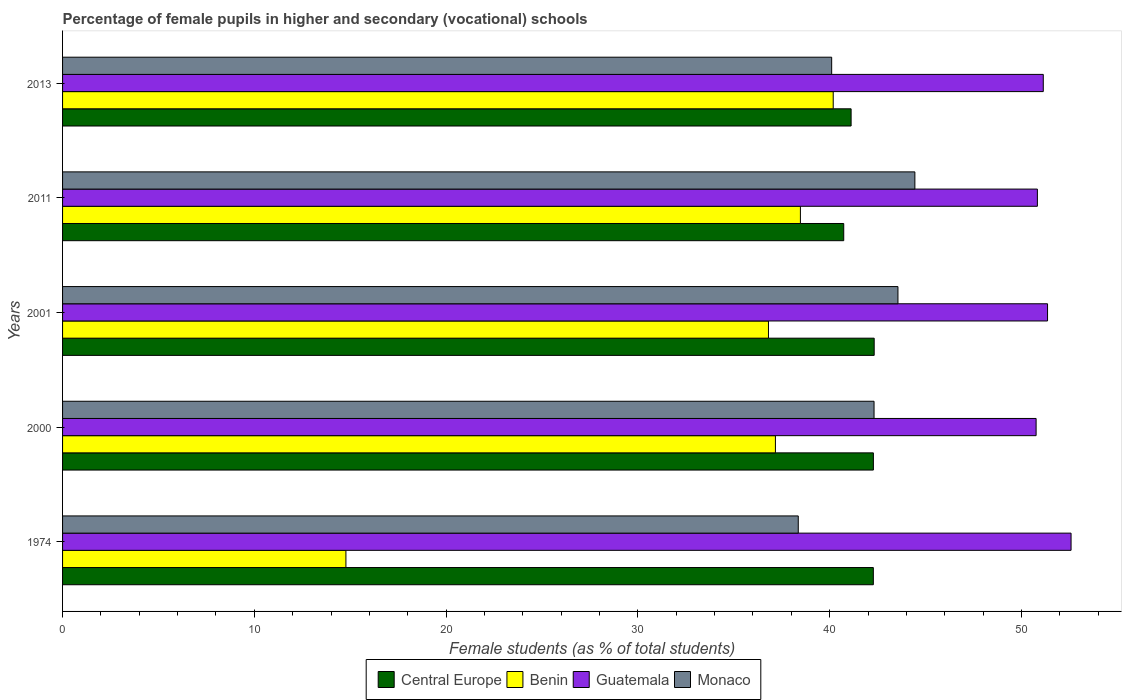How many different coloured bars are there?
Your answer should be compact. 4. How many groups of bars are there?
Keep it short and to the point. 5. Are the number of bars per tick equal to the number of legend labels?
Keep it short and to the point. Yes. Are the number of bars on each tick of the Y-axis equal?
Your response must be concise. Yes. How many bars are there on the 5th tick from the bottom?
Make the answer very short. 4. What is the label of the 2nd group of bars from the top?
Provide a succinct answer. 2011. What is the percentage of female pupils in higher and secondary schools in Benin in 2000?
Your response must be concise. 37.17. Across all years, what is the maximum percentage of female pupils in higher and secondary schools in Monaco?
Give a very brief answer. 44.44. Across all years, what is the minimum percentage of female pupils in higher and secondary schools in Benin?
Provide a short and direct response. 14.78. In which year was the percentage of female pupils in higher and secondary schools in Guatemala maximum?
Provide a short and direct response. 1974. What is the total percentage of female pupils in higher and secondary schools in Monaco in the graph?
Keep it short and to the point. 208.79. What is the difference between the percentage of female pupils in higher and secondary schools in Central Europe in 1974 and that in 2013?
Your answer should be compact. 1.16. What is the difference between the percentage of female pupils in higher and secondary schools in Central Europe in 2011 and the percentage of female pupils in higher and secondary schools in Guatemala in 2013?
Give a very brief answer. -10.41. What is the average percentage of female pupils in higher and secondary schools in Guatemala per year?
Offer a very short reply. 51.34. In the year 2013, what is the difference between the percentage of female pupils in higher and secondary schools in Central Europe and percentage of female pupils in higher and secondary schools in Monaco?
Offer a very short reply. 1.01. What is the ratio of the percentage of female pupils in higher and secondary schools in Guatemala in 2000 to that in 2011?
Offer a terse response. 1. Is the difference between the percentage of female pupils in higher and secondary schools in Central Europe in 1974 and 2013 greater than the difference between the percentage of female pupils in higher and secondary schools in Monaco in 1974 and 2013?
Offer a very short reply. Yes. What is the difference between the highest and the second highest percentage of female pupils in higher and secondary schools in Monaco?
Make the answer very short. 0.88. What is the difference between the highest and the lowest percentage of female pupils in higher and secondary schools in Central Europe?
Keep it short and to the point. 1.59. In how many years, is the percentage of female pupils in higher and secondary schools in Monaco greater than the average percentage of female pupils in higher and secondary schools in Monaco taken over all years?
Your response must be concise. 3. Is the sum of the percentage of female pupils in higher and secondary schools in Guatemala in 2011 and 2013 greater than the maximum percentage of female pupils in higher and secondary schools in Central Europe across all years?
Keep it short and to the point. Yes. Is it the case that in every year, the sum of the percentage of female pupils in higher and secondary schools in Central Europe and percentage of female pupils in higher and secondary schools in Monaco is greater than the sum of percentage of female pupils in higher and secondary schools in Benin and percentage of female pupils in higher and secondary schools in Guatemala?
Give a very brief answer. Yes. What does the 4th bar from the top in 1974 represents?
Keep it short and to the point. Central Europe. What does the 1st bar from the bottom in 2001 represents?
Give a very brief answer. Central Europe. Does the graph contain grids?
Give a very brief answer. No. How are the legend labels stacked?
Provide a succinct answer. Horizontal. What is the title of the graph?
Your response must be concise. Percentage of female pupils in higher and secondary (vocational) schools. What is the label or title of the X-axis?
Offer a terse response. Female students (as % of total students). What is the Female students (as % of total students) in Central Europe in 1974?
Your answer should be compact. 42.28. What is the Female students (as % of total students) in Benin in 1974?
Your answer should be compact. 14.78. What is the Female students (as % of total students) in Guatemala in 1974?
Keep it short and to the point. 52.59. What is the Female students (as % of total students) in Monaco in 1974?
Provide a short and direct response. 38.36. What is the Female students (as % of total students) of Central Europe in 2000?
Give a very brief answer. 42.28. What is the Female students (as % of total students) of Benin in 2000?
Your response must be concise. 37.17. What is the Female students (as % of total students) in Guatemala in 2000?
Give a very brief answer. 50.77. What is the Female students (as % of total students) in Monaco in 2000?
Offer a terse response. 42.32. What is the Female students (as % of total students) in Central Europe in 2001?
Offer a very short reply. 42.32. What is the Female students (as % of total students) of Benin in 2001?
Keep it short and to the point. 36.81. What is the Female students (as % of total students) in Guatemala in 2001?
Make the answer very short. 51.36. What is the Female students (as % of total students) in Monaco in 2001?
Your answer should be compact. 43.56. What is the Female students (as % of total students) of Central Europe in 2011?
Keep it short and to the point. 40.73. What is the Female students (as % of total students) in Benin in 2011?
Keep it short and to the point. 38.48. What is the Female students (as % of total students) in Guatemala in 2011?
Your answer should be compact. 50.83. What is the Female students (as % of total students) of Monaco in 2011?
Your answer should be compact. 44.44. What is the Female students (as % of total students) in Central Europe in 2013?
Your answer should be compact. 41.12. What is the Female students (as % of total students) of Benin in 2013?
Give a very brief answer. 40.19. What is the Female students (as % of total students) of Guatemala in 2013?
Your answer should be compact. 51.14. What is the Female students (as % of total students) in Monaco in 2013?
Keep it short and to the point. 40.11. Across all years, what is the maximum Female students (as % of total students) of Central Europe?
Offer a very short reply. 42.32. Across all years, what is the maximum Female students (as % of total students) in Benin?
Give a very brief answer. 40.19. Across all years, what is the maximum Female students (as % of total students) in Guatemala?
Your response must be concise. 52.59. Across all years, what is the maximum Female students (as % of total students) in Monaco?
Provide a succinct answer. 44.44. Across all years, what is the minimum Female students (as % of total students) in Central Europe?
Offer a very short reply. 40.73. Across all years, what is the minimum Female students (as % of total students) in Benin?
Provide a succinct answer. 14.78. Across all years, what is the minimum Female students (as % of total students) of Guatemala?
Your answer should be very brief. 50.77. Across all years, what is the minimum Female students (as % of total students) of Monaco?
Provide a short and direct response. 38.36. What is the total Female students (as % of total students) of Central Europe in the graph?
Give a very brief answer. 208.74. What is the total Female students (as % of total students) of Benin in the graph?
Make the answer very short. 167.42. What is the total Female students (as % of total students) of Guatemala in the graph?
Provide a succinct answer. 256.69. What is the total Female students (as % of total students) in Monaco in the graph?
Ensure brevity in your answer.  208.79. What is the difference between the Female students (as % of total students) of Central Europe in 1974 and that in 2000?
Give a very brief answer. -0. What is the difference between the Female students (as % of total students) of Benin in 1974 and that in 2000?
Give a very brief answer. -22.4. What is the difference between the Female students (as % of total students) of Guatemala in 1974 and that in 2000?
Make the answer very short. 1.82. What is the difference between the Female students (as % of total students) in Monaco in 1974 and that in 2000?
Provide a succinct answer. -3.95. What is the difference between the Female students (as % of total students) in Central Europe in 1974 and that in 2001?
Offer a very short reply. -0.04. What is the difference between the Female students (as % of total students) in Benin in 1974 and that in 2001?
Your response must be concise. -22.03. What is the difference between the Female students (as % of total students) in Guatemala in 1974 and that in 2001?
Your answer should be compact. 1.23. What is the difference between the Female students (as % of total students) of Monaco in 1974 and that in 2001?
Provide a short and direct response. -5.2. What is the difference between the Female students (as % of total students) of Central Europe in 1974 and that in 2011?
Provide a succinct answer. 1.54. What is the difference between the Female students (as % of total students) of Benin in 1974 and that in 2011?
Your answer should be very brief. -23.7. What is the difference between the Female students (as % of total students) of Guatemala in 1974 and that in 2011?
Offer a terse response. 1.76. What is the difference between the Female students (as % of total students) in Monaco in 1974 and that in 2011?
Provide a short and direct response. -6.08. What is the difference between the Female students (as % of total students) in Central Europe in 1974 and that in 2013?
Keep it short and to the point. 1.16. What is the difference between the Female students (as % of total students) of Benin in 1974 and that in 2013?
Offer a very short reply. -25.41. What is the difference between the Female students (as % of total students) of Guatemala in 1974 and that in 2013?
Make the answer very short. 1.45. What is the difference between the Female students (as % of total students) of Monaco in 1974 and that in 2013?
Your response must be concise. -1.74. What is the difference between the Female students (as % of total students) of Central Europe in 2000 and that in 2001?
Offer a very short reply. -0.04. What is the difference between the Female students (as % of total students) of Benin in 2000 and that in 2001?
Provide a succinct answer. 0.36. What is the difference between the Female students (as % of total students) in Guatemala in 2000 and that in 2001?
Ensure brevity in your answer.  -0.6. What is the difference between the Female students (as % of total students) in Monaco in 2000 and that in 2001?
Give a very brief answer. -1.25. What is the difference between the Female students (as % of total students) of Central Europe in 2000 and that in 2011?
Make the answer very short. 1.55. What is the difference between the Female students (as % of total students) in Benin in 2000 and that in 2011?
Give a very brief answer. -1.3. What is the difference between the Female students (as % of total students) in Guatemala in 2000 and that in 2011?
Provide a succinct answer. -0.07. What is the difference between the Female students (as % of total students) of Monaco in 2000 and that in 2011?
Keep it short and to the point. -2.13. What is the difference between the Female students (as % of total students) of Central Europe in 2000 and that in 2013?
Your answer should be compact. 1.16. What is the difference between the Female students (as % of total students) of Benin in 2000 and that in 2013?
Provide a succinct answer. -3.01. What is the difference between the Female students (as % of total students) in Guatemala in 2000 and that in 2013?
Keep it short and to the point. -0.37. What is the difference between the Female students (as % of total students) of Monaco in 2000 and that in 2013?
Make the answer very short. 2.21. What is the difference between the Female students (as % of total students) of Central Europe in 2001 and that in 2011?
Your response must be concise. 1.59. What is the difference between the Female students (as % of total students) in Benin in 2001 and that in 2011?
Your response must be concise. -1.67. What is the difference between the Female students (as % of total students) of Guatemala in 2001 and that in 2011?
Give a very brief answer. 0.53. What is the difference between the Female students (as % of total students) of Monaco in 2001 and that in 2011?
Give a very brief answer. -0.88. What is the difference between the Female students (as % of total students) in Central Europe in 2001 and that in 2013?
Your answer should be compact. 1.2. What is the difference between the Female students (as % of total students) in Benin in 2001 and that in 2013?
Your response must be concise. -3.38. What is the difference between the Female students (as % of total students) of Guatemala in 2001 and that in 2013?
Your answer should be very brief. 0.22. What is the difference between the Female students (as % of total students) in Monaco in 2001 and that in 2013?
Keep it short and to the point. 3.46. What is the difference between the Female students (as % of total students) in Central Europe in 2011 and that in 2013?
Provide a short and direct response. -0.38. What is the difference between the Female students (as % of total students) in Benin in 2011 and that in 2013?
Provide a succinct answer. -1.71. What is the difference between the Female students (as % of total students) of Guatemala in 2011 and that in 2013?
Offer a very short reply. -0.31. What is the difference between the Female students (as % of total students) in Monaco in 2011 and that in 2013?
Offer a terse response. 4.34. What is the difference between the Female students (as % of total students) of Central Europe in 1974 and the Female students (as % of total students) of Benin in 2000?
Offer a terse response. 5.11. What is the difference between the Female students (as % of total students) in Central Europe in 1974 and the Female students (as % of total students) in Guatemala in 2000?
Offer a terse response. -8.49. What is the difference between the Female students (as % of total students) of Central Europe in 1974 and the Female students (as % of total students) of Monaco in 2000?
Provide a succinct answer. -0.04. What is the difference between the Female students (as % of total students) in Benin in 1974 and the Female students (as % of total students) in Guatemala in 2000?
Your answer should be very brief. -35.99. What is the difference between the Female students (as % of total students) of Benin in 1974 and the Female students (as % of total students) of Monaco in 2000?
Provide a short and direct response. -27.54. What is the difference between the Female students (as % of total students) of Guatemala in 1974 and the Female students (as % of total students) of Monaco in 2000?
Give a very brief answer. 10.27. What is the difference between the Female students (as % of total students) in Central Europe in 1974 and the Female students (as % of total students) in Benin in 2001?
Offer a very short reply. 5.47. What is the difference between the Female students (as % of total students) in Central Europe in 1974 and the Female students (as % of total students) in Guatemala in 2001?
Ensure brevity in your answer.  -9.08. What is the difference between the Female students (as % of total students) in Central Europe in 1974 and the Female students (as % of total students) in Monaco in 2001?
Your response must be concise. -1.28. What is the difference between the Female students (as % of total students) of Benin in 1974 and the Female students (as % of total students) of Guatemala in 2001?
Make the answer very short. -36.59. What is the difference between the Female students (as % of total students) in Benin in 1974 and the Female students (as % of total students) in Monaco in 2001?
Provide a succinct answer. -28.79. What is the difference between the Female students (as % of total students) in Guatemala in 1974 and the Female students (as % of total students) in Monaco in 2001?
Give a very brief answer. 9.03. What is the difference between the Female students (as % of total students) in Central Europe in 1974 and the Female students (as % of total students) in Benin in 2011?
Give a very brief answer. 3.8. What is the difference between the Female students (as % of total students) in Central Europe in 1974 and the Female students (as % of total students) in Guatemala in 2011?
Provide a succinct answer. -8.56. What is the difference between the Female students (as % of total students) in Central Europe in 1974 and the Female students (as % of total students) in Monaco in 2011?
Your answer should be very brief. -2.17. What is the difference between the Female students (as % of total students) in Benin in 1974 and the Female students (as % of total students) in Guatemala in 2011?
Your answer should be compact. -36.06. What is the difference between the Female students (as % of total students) of Benin in 1974 and the Female students (as % of total students) of Monaco in 2011?
Your answer should be very brief. -29.67. What is the difference between the Female students (as % of total students) of Guatemala in 1974 and the Female students (as % of total students) of Monaco in 2011?
Your answer should be compact. 8.14. What is the difference between the Female students (as % of total students) in Central Europe in 1974 and the Female students (as % of total students) in Benin in 2013?
Offer a terse response. 2.09. What is the difference between the Female students (as % of total students) in Central Europe in 1974 and the Female students (as % of total students) in Guatemala in 2013?
Provide a succinct answer. -8.86. What is the difference between the Female students (as % of total students) in Central Europe in 1974 and the Female students (as % of total students) in Monaco in 2013?
Ensure brevity in your answer.  2.17. What is the difference between the Female students (as % of total students) of Benin in 1974 and the Female students (as % of total students) of Guatemala in 2013?
Your answer should be very brief. -36.36. What is the difference between the Female students (as % of total students) in Benin in 1974 and the Female students (as % of total students) in Monaco in 2013?
Your answer should be very brief. -25.33. What is the difference between the Female students (as % of total students) of Guatemala in 1974 and the Female students (as % of total students) of Monaco in 2013?
Keep it short and to the point. 12.48. What is the difference between the Female students (as % of total students) of Central Europe in 2000 and the Female students (as % of total students) of Benin in 2001?
Provide a short and direct response. 5.47. What is the difference between the Female students (as % of total students) in Central Europe in 2000 and the Female students (as % of total students) in Guatemala in 2001?
Ensure brevity in your answer.  -9.08. What is the difference between the Female students (as % of total students) of Central Europe in 2000 and the Female students (as % of total students) of Monaco in 2001?
Offer a very short reply. -1.28. What is the difference between the Female students (as % of total students) in Benin in 2000 and the Female students (as % of total students) in Guatemala in 2001?
Offer a very short reply. -14.19. What is the difference between the Female students (as % of total students) in Benin in 2000 and the Female students (as % of total students) in Monaco in 2001?
Your answer should be very brief. -6.39. What is the difference between the Female students (as % of total students) of Guatemala in 2000 and the Female students (as % of total students) of Monaco in 2001?
Offer a terse response. 7.2. What is the difference between the Female students (as % of total students) of Central Europe in 2000 and the Female students (as % of total students) of Benin in 2011?
Offer a terse response. 3.81. What is the difference between the Female students (as % of total students) of Central Europe in 2000 and the Female students (as % of total students) of Guatemala in 2011?
Your answer should be very brief. -8.55. What is the difference between the Female students (as % of total students) of Central Europe in 2000 and the Female students (as % of total students) of Monaco in 2011?
Your response must be concise. -2.16. What is the difference between the Female students (as % of total students) of Benin in 2000 and the Female students (as % of total students) of Guatemala in 2011?
Provide a short and direct response. -13.66. What is the difference between the Female students (as % of total students) in Benin in 2000 and the Female students (as % of total students) in Monaco in 2011?
Offer a very short reply. -7.27. What is the difference between the Female students (as % of total students) of Guatemala in 2000 and the Female students (as % of total students) of Monaco in 2011?
Offer a very short reply. 6.32. What is the difference between the Female students (as % of total students) in Central Europe in 2000 and the Female students (as % of total students) in Benin in 2013?
Make the answer very short. 2.1. What is the difference between the Female students (as % of total students) of Central Europe in 2000 and the Female students (as % of total students) of Guatemala in 2013?
Keep it short and to the point. -8.86. What is the difference between the Female students (as % of total students) of Central Europe in 2000 and the Female students (as % of total students) of Monaco in 2013?
Your answer should be very brief. 2.18. What is the difference between the Female students (as % of total students) of Benin in 2000 and the Female students (as % of total students) of Guatemala in 2013?
Give a very brief answer. -13.97. What is the difference between the Female students (as % of total students) of Benin in 2000 and the Female students (as % of total students) of Monaco in 2013?
Give a very brief answer. -2.93. What is the difference between the Female students (as % of total students) of Guatemala in 2000 and the Female students (as % of total students) of Monaco in 2013?
Provide a succinct answer. 10.66. What is the difference between the Female students (as % of total students) in Central Europe in 2001 and the Female students (as % of total students) in Benin in 2011?
Ensure brevity in your answer.  3.85. What is the difference between the Female students (as % of total students) in Central Europe in 2001 and the Female students (as % of total students) in Guatemala in 2011?
Provide a succinct answer. -8.51. What is the difference between the Female students (as % of total students) of Central Europe in 2001 and the Female students (as % of total students) of Monaco in 2011?
Your response must be concise. -2.12. What is the difference between the Female students (as % of total students) in Benin in 2001 and the Female students (as % of total students) in Guatemala in 2011?
Offer a very short reply. -14.02. What is the difference between the Female students (as % of total students) in Benin in 2001 and the Female students (as % of total students) in Monaco in 2011?
Give a very brief answer. -7.63. What is the difference between the Female students (as % of total students) in Guatemala in 2001 and the Female students (as % of total students) in Monaco in 2011?
Your answer should be compact. 6.92. What is the difference between the Female students (as % of total students) in Central Europe in 2001 and the Female students (as % of total students) in Benin in 2013?
Keep it short and to the point. 2.14. What is the difference between the Female students (as % of total students) in Central Europe in 2001 and the Female students (as % of total students) in Guatemala in 2013?
Provide a succinct answer. -8.82. What is the difference between the Female students (as % of total students) of Central Europe in 2001 and the Female students (as % of total students) of Monaco in 2013?
Offer a very short reply. 2.22. What is the difference between the Female students (as % of total students) of Benin in 2001 and the Female students (as % of total students) of Guatemala in 2013?
Keep it short and to the point. -14.33. What is the difference between the Female students (as % of total students) in Benin in 2001 and the Female students (as % of total students) in Monaco in 2013?
Offer a very short reply. -3.3. What is the difference between the Female students (as % of total students) in Guatemala in 2001 and the Female students (as % of total students) in Monaco in 2013?
Your answer should be compact. 11.26. What is the difference between the Female students (as % of total students) of Central Europe in 2011 and the Female students (as % of total students) of Benin in 2013?
Offer a very short reply. 0.55. What is the difference between the Female students (as % of total students) of Central Europe in 2011 and the Female students (as % of total students) of Guatemala in 2013?
Provide a short and direct response. -10.41. What is the difference between the Female students (as % of total students) of Central Europe in 2011 and the Female students (as % of total students) of Monaco in 2013?
Provide a succinct answer. 0.63. What is the difference between the Female students (as % of total students) of Benin in 2011 and the Female students (as % of total students) of Guatemala in 2013?
Offer a terse response. -12.66. What is the difference between the Female students (as % of total students) in Benin in 2011 and the Female students (as % of total students) in Monaco in 2013?
Ensure brevity in your answer.  -1.63. What is the difference between the Female students (as % of total students) in Guatemala in 2011 and the Female students (as % of total students) in Monaco in 2013?
Offer a very short reply. 10.73. What is the average Female students (as % of total students) of Central Europe per year?
Offer a terse response. 41.75. What is the average Female students (as % of total students) of Benin per year?
Your answer should be very brief. 33.48. What is the average Female students (as % of total students) of Guatemala per year?
Give a very brief answer. 51.34. What is the average Female students (as % of total students) of Monaco per year?
Your response must be concise. 41.76. In the year 1974, what is the difference between the Female students (as % of total students) in Central Europe and Female students (as % of total students) in Benin?
Offer a very short reply. 27.5. In the year 1974, what is the difference between the Female students (as % of total students) of Central Europe and Female students (as % of total students) of Guatemala?
Your answer should be very brief. -10.31. In the year 1974, what is the difference between the Female students (as % of total students) of Central Europe and Female students (as % of total students) of Monaco?
Ensure brevity in your answer.  3.91. In the year 1974, what is the difference between the Female students (as % of total students) of Benin and Female students (as % of total students) of Guatemala?
Your response must be concise. -37.81. In the year 1974, what is the difference between the Female students (as % of total students) of Benin and Female students (as % of total students) of Monaco?
Ensure brevity in your answer.  -23.59. In the year 1974, what is the difference between the Female students (as % of total students) in Guatemala and Female students (as % of total students) in Monaco?
Your answer should be compact. 14.23. In the year 2000, what is the difference between the Female students (as % of total students) of Central Europe and Female students (as % of total students) of Benin?
Your answer should be compact. 5.11. In the year 2000, what is the difference between the Female students (as % of total students) in Central Europe and Female students (as % of total students) in Guatemala?
Give a very brief answer. -8.49. In the year 2000, what is the difference between the Female students (as % of total students) of Central Europe and Female students (as % of total students) of Monaco?
Your answer should be very brief. -0.03. In the year 2000, what is the difference between the Female students (as % of total students) in Benin and Female students (as % of total students) in Guatemala?
Provide a succinct answer. -13.59. In the year 2000, what is the difference between the Female students (as % of total students) in Benin and Female students (as % of total students) in Monaco?
Offer a very short reply. -5.14. In the year 2000, what is the difference between the Female students (as % of total students) of Guatemala and Female students (as % of total students) of Monaco?
Offer a terse response. 8.45. In the year 2001, what is the difference between the Female students (as % of total students) in Central Europe and Female students (as % of total students) in Benin?
Provide a short and direct response. 5.51. In the year 2001, what is the difference between the Female students (as % of total students) in Central Europe and Female students (as % of total students) in Guatemala?
Your answer should be very brief. -9.04. In the year 2001, what is the difference between the Female students (as % of total students) of Central Europe and Female students (as % of total students) of Monaco?
Give a very brief answer. -1.24. In the year 2001, what is the difference between the Female students (as % of total students) of Benin and Female students (as % of total students) of Guatemala?
Offer a very short reply. -14.55. In the year 2001, what is the difference between the Female students (as % of total students) in Benin and Female students (as % of total students) in Monaco?
Provide a short and direct response. -6.75. In the year 2001, what is the difference between the Female students (as % of total students) of Guatemala and Female students (as % of total students) of Monaco?
Offer a terse response. 7.8. In the year 2011, what is the difference between the Female students (as % of total students) of Central Europe and Female students (as % of total students) of Benin?
Your answer should be very brief. 2.26. In the year 2011, what is the difference between the Female students (as % of total students) of Central Europe and Female students (as % of total students) of Guatemala?
Offer a terse response. -10.1. In the year 2011, what is the difference between the Female students (as % of total students) in Central Europe and Female students (as % of total students) in Monaco?
Make the answer very short. -3.71. In the year 2011, what is the difference between the Female students (as % of total students) in Benin and Female students (as % of total students) in Guatemala?
Your response must be concise. -12.36. In the year 2011, what is the difference between the Female students (as % of total students) of Benin and Female students (as % of total students) of Monaco?
Make the answer very short. -5.97. In the year 2011, what is the difference between the Female students (as % of total students) of Guatemala and Female students (as % of total students) of Monaco?
Provide a short and direct response. 6.39. In the year 2013, what is the difference between the Female students (as % of total students) of Central Europe and Female students (as % of total students) of Benin?
Keep it short and to the point. 0.93. In the year 2013, what is the difference between the Female students (as % of total students) of Central Europe and Female students (as % of total students) of Guatemala?
Provide a short and direct response. -10.02. In the year 2013, what is the difference between the Female students (as % of total students) in Central Europe and Female students (as % of total students) in Monaco?
Provide a succinct answer. 1.01. In the year 2013, what is the difference between the Female students (as % of total students) of Benin and Female students (as % of total students) of Guatemala?
Provide a succinct answer. -10.95. In the year 2013, what is the difference between the Female students (as % of total students) in Benin and Female students (as % of total students) in Monaco?
Give a very brief answer. 0.08. In the year 2013, what is the difference between the Female students (as % of total students) of Guatemala and Female students (as % of total students) of Monaco?
Your response must be concise. 11.04. What is the ratio of the Female students (as % of total students) of Benin in 1974 to that in 2000?
Offer a terse response. 0.4. What is the ratio of the Female students (as % of total students) of Guatemala in 1974 to that in 2000?
Offer a terse response. 1.04. What is the ratio of the Female students (as % of total students) of Monaco in 1974 to that in 2000?
Your response must be concise. 0.91. What is the ratio of the Female students (as % of total students) in Benin in 1974 to that in 2001?
Offer a very short reply. 0.4. What is the ratio of the Female students (as % of total students) in Guatemala in 1974 to that in 2001?
Your response must be concise. 1.02. What is the ratio of the Female students (as % of total students) in Monaco in 1974 to that in 2001?
Ensure brevity in your answer.  0.88. What is the ratio of the Female students (as % of total students) of Central Europe in 1974 to that in 2011?
Offer a very short reply. 1.04. What is the ratio of the Female students (as % of total students) of Benin in 1974 to that in 2011?
Offer a very short reply. 0.38. What is the ratio of the Female students (as % of total students) in Guatemala in 1974 to that in 2011?
Offer a very short reply. 1.03. What is the ratio of the Female students (as % of total students) in Monaco in 1974 to that in 2011?
Provide a short and direct response. 0.86. What is the ratio of the Female students (as % of total students) in Central Europe in 1974 to that in 2013?
Provide a succinct answer. 1.03. What is the ratio of the Female students (as % of total students) in Benin in 1974 to that in 2013?
Make the answer very short. 0.37. What is the ratio of the Female students (as % of total students) of Guatemala in 1974 to that in 2013?
Your answer should be compact. 1.03. What is the ratio of the Female students (as % of total students) of Monaco in 1974 to that in 2013?
Your answer should be very brief. 0.96. What is the ratio of the Female students (as % of total students) in Benin in 2000 to that in 2001?
Ensure brevity in your answer.  1.01. What is the ratio of the Female students (as % of total students) in Guatemala in 2000 to that in 2001?
Give a very brief answer. 0.99. What is the ratio of the Female students (as % of total students) of Monaco in 2000 to that in 2001?
Your answer should be compact. 0.97. What is the ratio of the Female students (as % of total students) of Central Europe in 2000 to that in 2011?
Provide a succinct answer. 1.04. What is the ratio of the Female students (as % of total students) in Benin in 2000 to that in 2011?
Make the answer very short. 0.97. What is the ratio of the Female students (as % of total students) in Monaco in 2000 to that in 2011?
Give a very brief answer. 0.95. What is the ratio of the Female students (as % of total students) in Central Europe in 2000 to that in 2013?
Offer a very short reply. 1.03. What is the ratio of the Female students (as % of total students) of Benin in 2000 to that in 2013?
Offer a terse response. 0.93. What is the ratio of the Female students (as % of total students) in Guatemala in 2000 to that in 2013?
Give a very brief answer. 0.99. What is the ratio of the Female students (as % of total students) in Monaco in 2000 to that in 2013?
Provide a short and direct response. 1.06. What is the ratio of the Female students (as % of total students) in Central Europe in 2001 to that in 2011?
Offer a very short reply. 1.04. What is the ratio of the Female students (as % of total students) of Benin in 2001 to that in 2011?
Make the answer very short. 0.96. What is the ratio of the Female students (as % of total students) in Guatemala in 2001 to that in 2011?
Your response must be concise. 1.01. What is the ratio of the Female students (as % of total students) in Monaco in 2001 to that in 2011?
Keep it short and to the point. 0.98. What is the ratio of the Female students (as % of total students) of Central Europe in 2001 to that in 2013?
Give a very brief answer. 1.03. What is the ratio of the Female students (as % of total students) in Benin in 2001 to that in 2013?
Make the answer very short. 0.92. What is the ratio of the Female students (as % of total students) of Guatemala in 2001 to that in 2013?
Ensure brevity in your answer.  1. What is the ratio of the Female students (as % of total students) of Monaco in 2001 to that in 2013?
Provide a short and direct response. 1.09. What is the ratio of the Female students (as % of total students) in Central Europe in 2011 to that in 2013?
Give a very brief answer. 0.99. What is the ratio of the Female students (as % of total students) of Benin in 2011 to that in 2013?
Your response must be concise. 0.96. What is the ratio of the Female students (as % of total students) in Monaco in 2011 to that in 2013?
Your answer should be compact. 1.11. What is the difference between the highest and the second highest Female students (as % of total students) of Central Europe?
Ensure brevity in your answer.  0.04. What is the difference between the highest and the second highest Female students (as % of total students) in Benin?
Your response must be concise. 1.71. What is the difference between the highest and the second highest Female students (as % of total students) in Guatemala?
Offer a terse response. 1.23. What is the difference between the highest and the second highest Female students (as % of total students) of Monaco?
Your answer should be compact. 0.88. What is the difference between the highest and the lowest Female students (as % of total students) in Central Europe?
Ensure brevity in your answer.  1.59. What is the difference between the highest and the lowest Female students (as % of total students) in Benin?
Your answer should be very brief. 25.41. What is the difference between the highest and the lowest Female students (as % of total students) of Guatemala?
Ensure brevity in your answer.  1.82. What is the difference between the highest and the lowest Female students (as % of total students) in Monaco?
Ensure brevity in your answer.  6.08. 